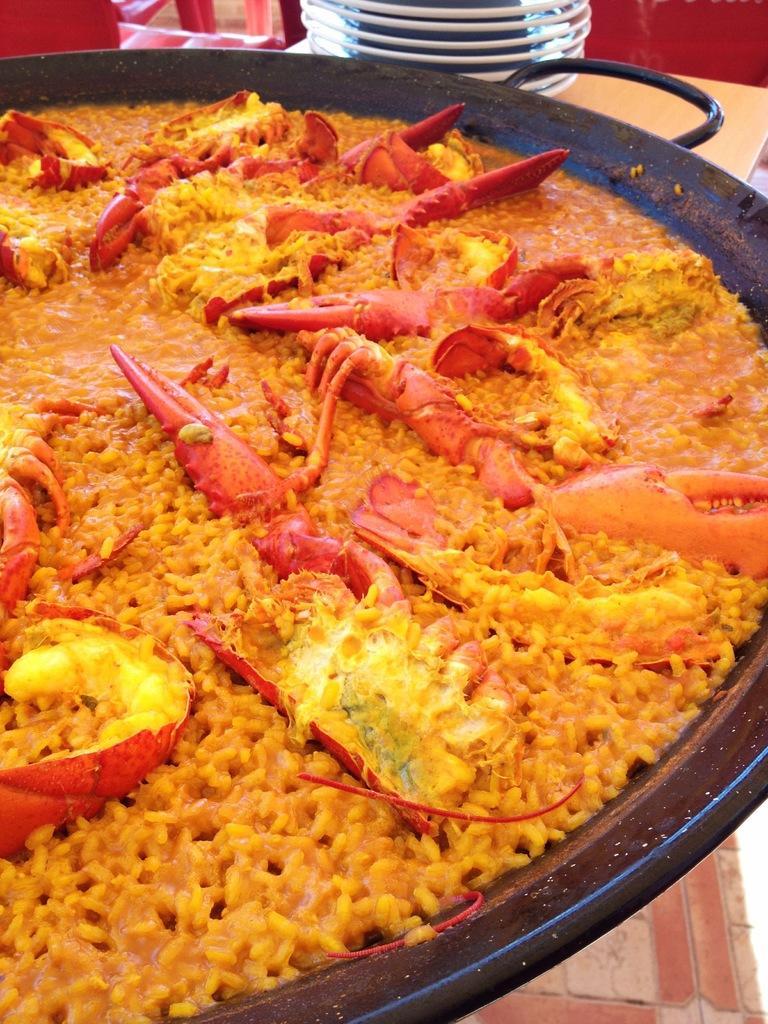In one or two sentences, can you explain what this image depicts? In the center of the image, we can see food in the container and in the background, there are plates, some objects and there is a table. 